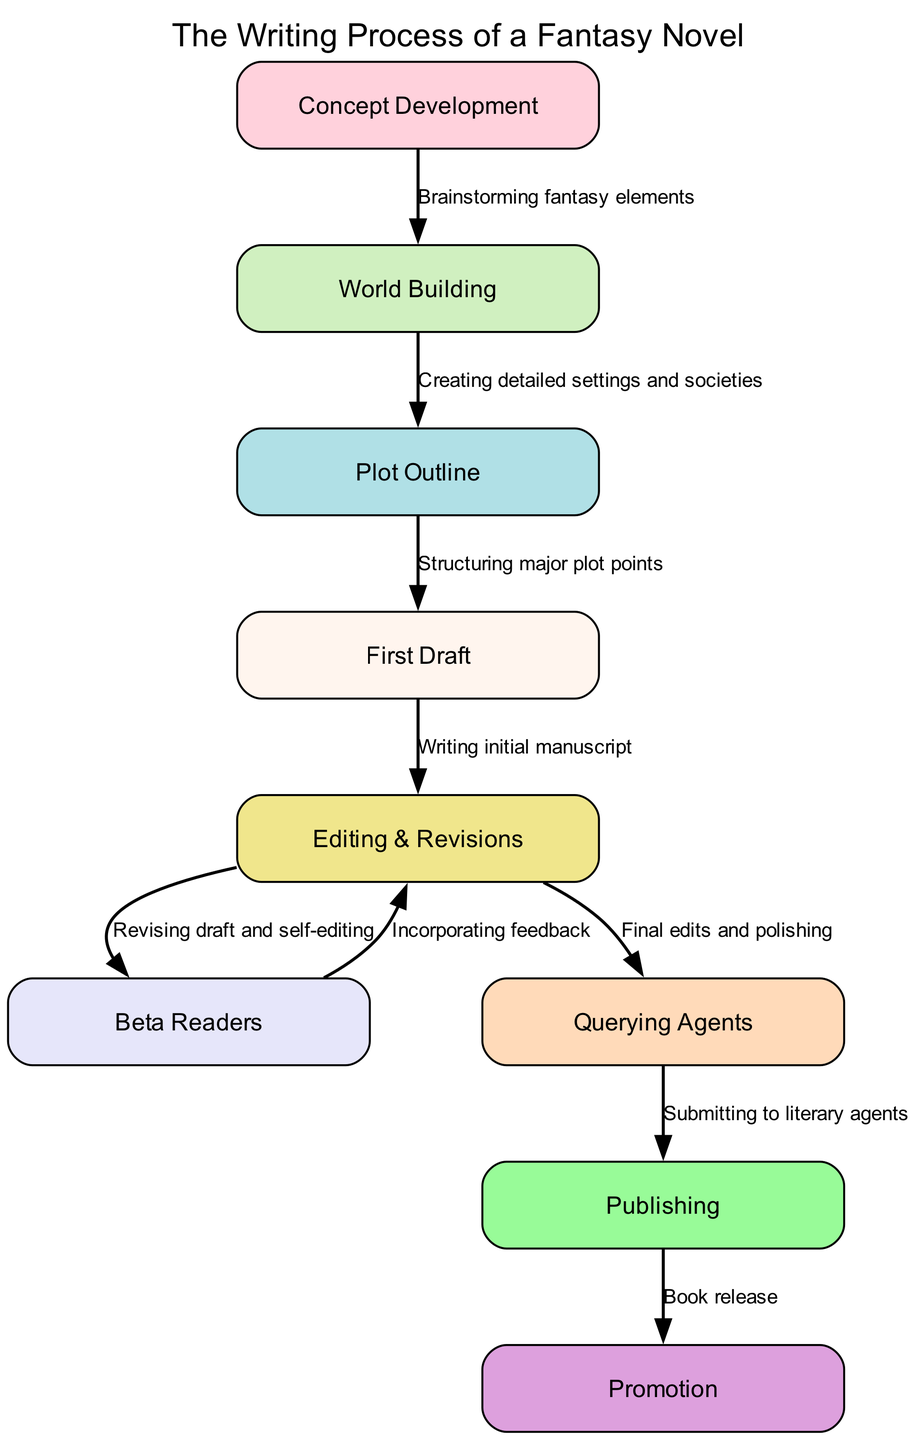What is the first stage in the writing process? The diagram indicates that the first node or stage in the writing process is "Concept Development".
Answer: Concept Development How many nodes are present in the diagram? By counting the listed nodes in the diagram, we see there are 8 different stages depicted.
Answer: 8 What is the label of the last stage in the flowchart? The last node in the diagram is labeled "Promotion", which is the final stage of the writing process.
Answer: Promotion What is the relationship between "Editing & Revisions" and "Beta Readers"? The diagram shows an edge from "Editing & Revisions" to "Beta Readers", indicating that the process involves incorporating feedback from beta readers after revising the draft.
Answer: Incorporating feedback Which stage comes after "First Draft"? The flowchart reveals that the next stage after "First Draft" is "Editing & Revisions".
Answer: Editing & Revisions How many edges connect the nodes in the diagram? Upon examining the connections or edges between the nodes, the diagram contains a total of 9 edges representing the relationships between the stages.
Answer: 9 What stage is directly linked to "Querying Agents"? The diagram shows that "Publishing" is directly linked to "Querying Agents", signifying that querying occurs before the publishing stage.
Answer: Publishing What is one linear path from concept to publication? The flow follows "Concept Development" to "World Building," then "Plot Outline," followed by "First Draft," "Editing & Revisions," "Beta Readers," "Querying Agents," and finally to "Publishing". This gives a complete path from the concept to publication.
Answer: Concept Development → World Building → Plot Outline → First Draft → Editing & Revisions → Beta Readers → Querying Agents → Publishing 